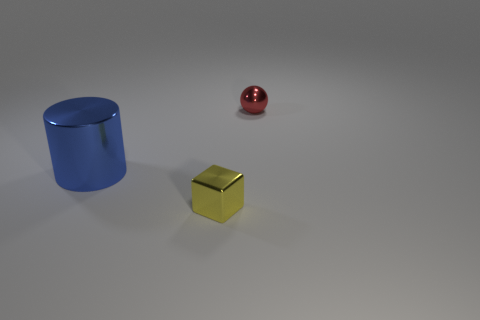Add 2 blocks. How many objects exist? 5 Subtract all blocks. How many objects are left? 2 Subtract all tiny objects. Subtract all big yellow rubber things. How many objects are left? 1 Add 2 small shiny spheres. How many small shiny spheres are left? 3 Add 1 metal cylinders. How many metal cylinders exist? 2 Subtract 1 blue cylinders. How many objects are left? 2 Subtract all cyan spheres. Subtract all yellow cylinders. How many spheres are left? 1 